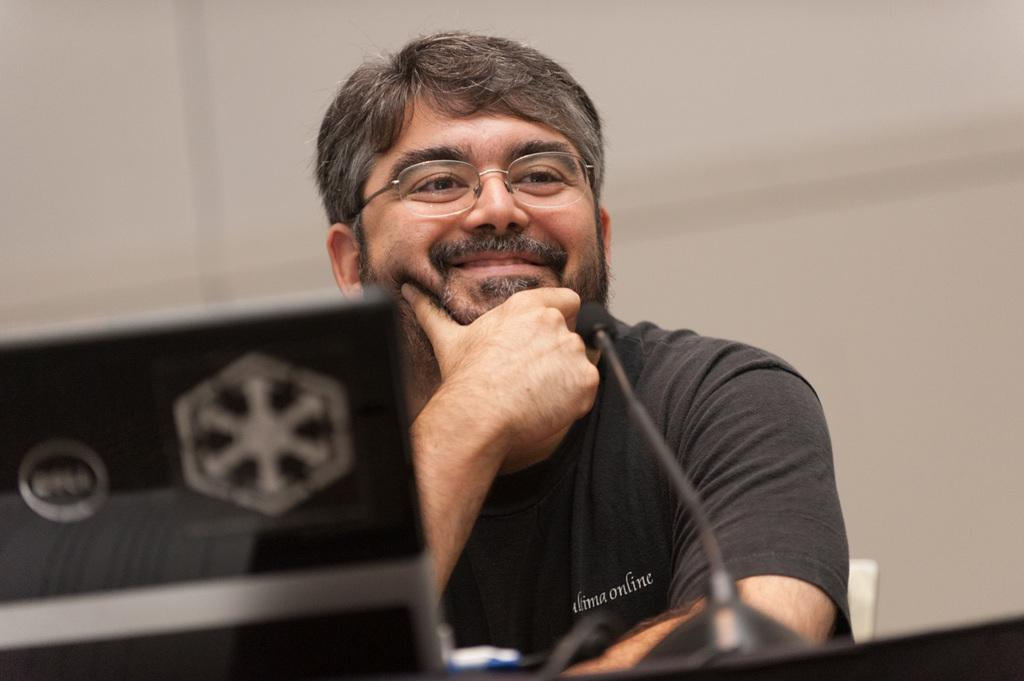What is the person in the image doing? The person is sitting in the image. What is the person's facial expression? The person is smiling. What object is in front of the person? There is a microphone (mike) in front of the person. What is on the platform in front of the person? There is an object on a platform in front of the person. What color is the background of the image? The background of the image is white. How does the monkey react to the person's smile in the image? There is no monkey present in the image, so it is not possible to determine how a monkey might react to the person's smile. 